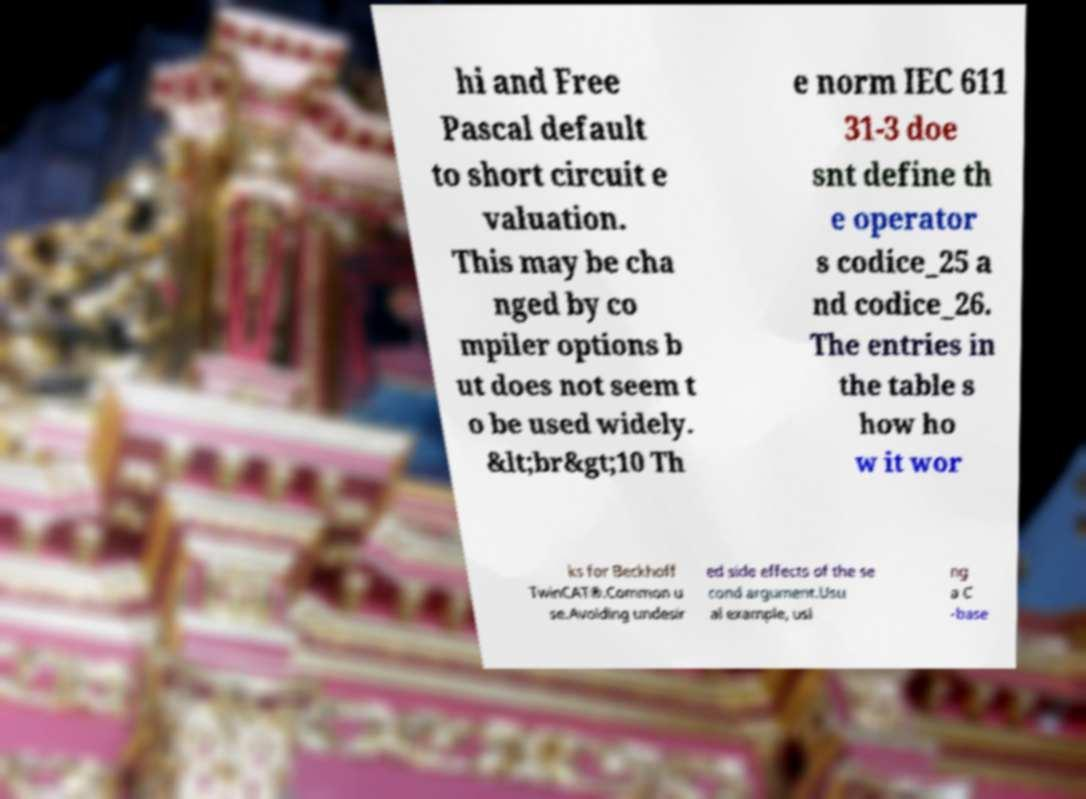There's text embedded in this image that I need extracted. Can you transcribe it verbatim? hi and Free Pascal default to short circuit e valuation. This may be cha nged by co mpiler options b ut does not seem t o be used widely. &lt;br&gt;10 Th e norm IEC 611 31-3 doe snt define th e operator s codice_25 a nd codice_26. The entries in the table s how ho w it wor ks for Beckhoff TwinCAT®.Common u se.Avoiding undesir ed side effects of the se cond argument.Usu al example, usi ng a C -base 